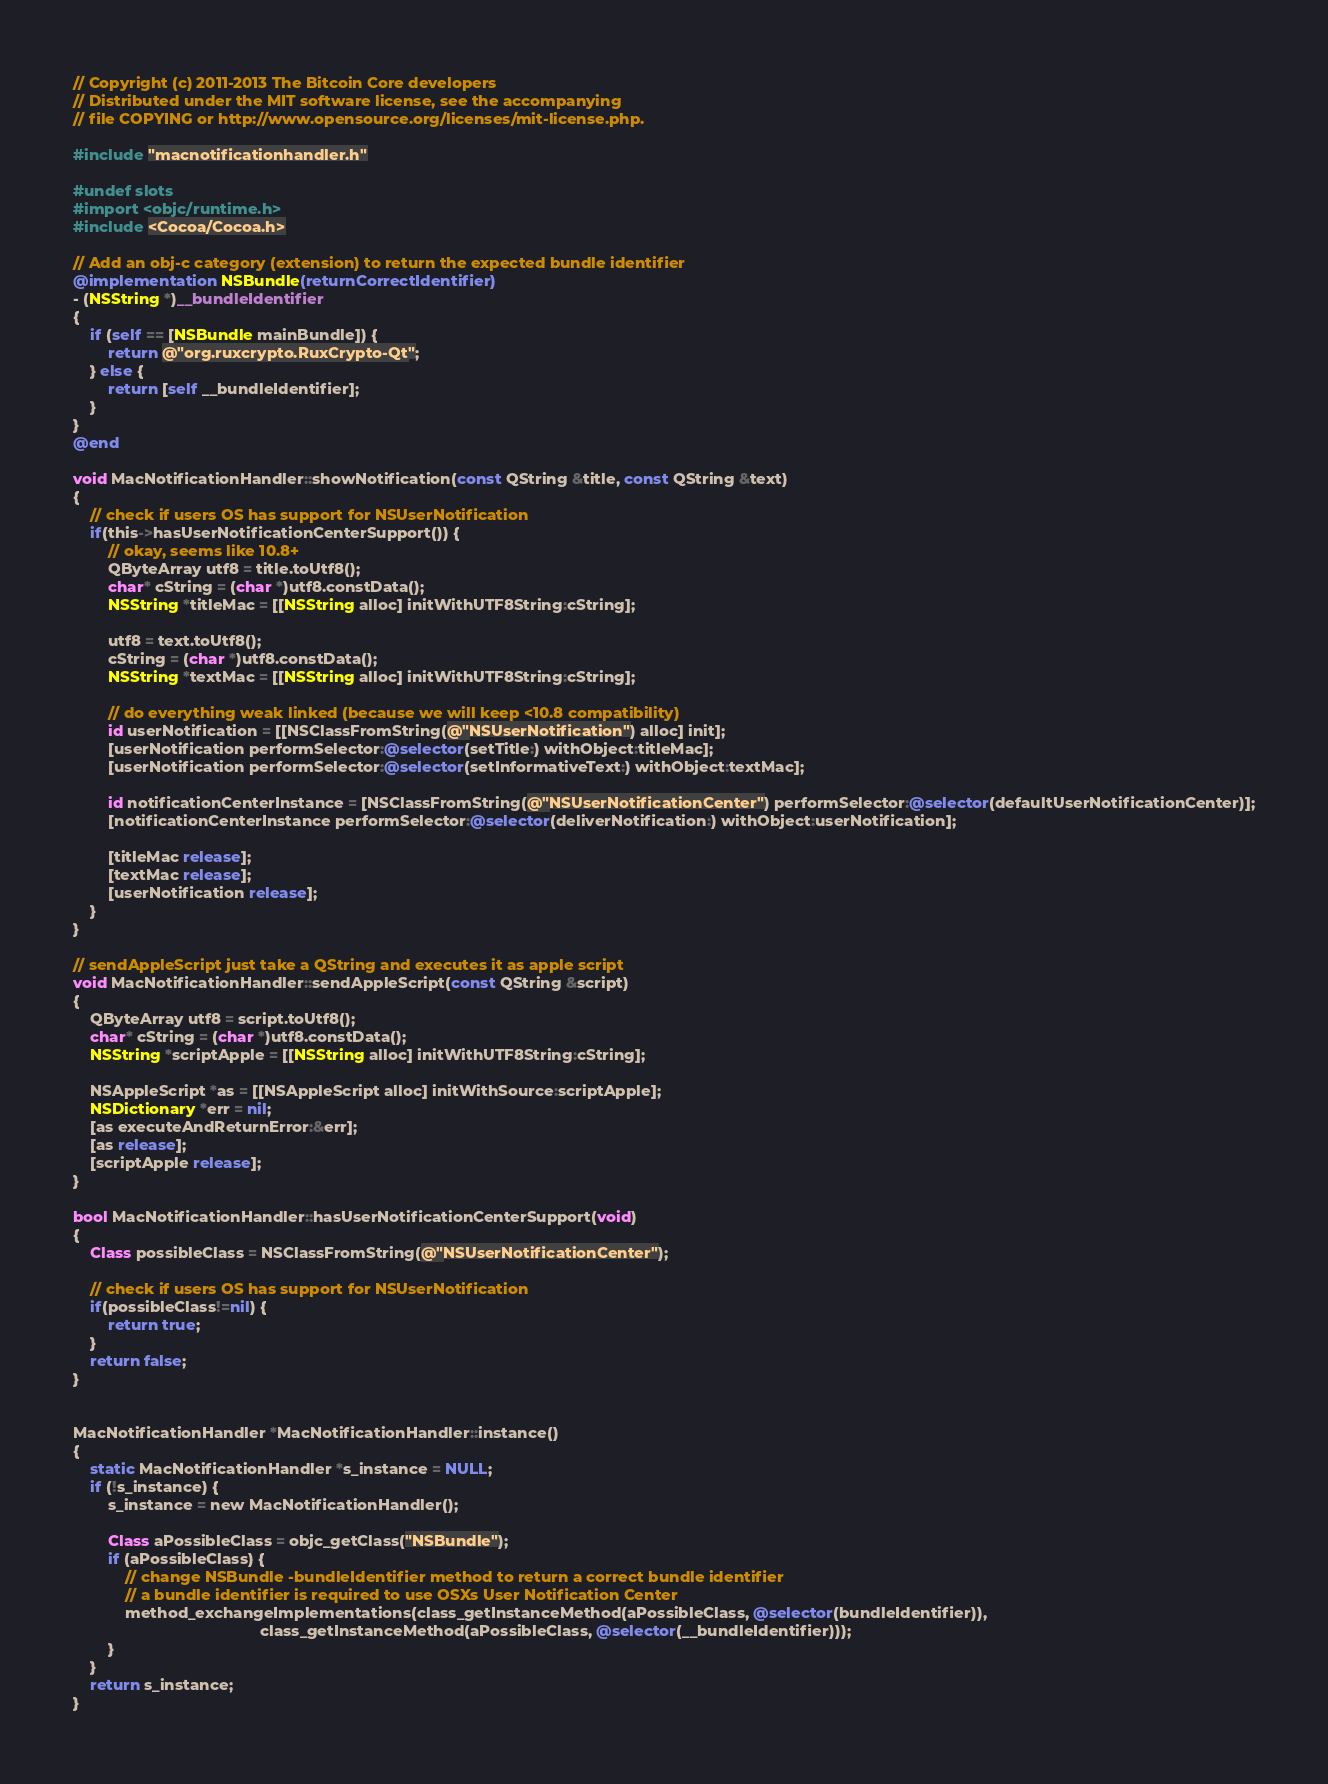<code> <loc_0><loc_0><loc_500><loc_500><_ObjectiveC_>// Copyright (c) 2011-2013 The Bitcoin Core developers
// Distributed under the MIT software license, see the accompanying
// file COPYING or http://www.opensource.org/licenses/mit-license.php.

#include "macnotificationhandler.h"

#undef slots
#import <objc/runtime.h>
#include <Cocoa/Cocoa.h>

// Add an obj-c category (extension) to return the expected bundle identifier
@implementation NSBundle(returnCorrectIdentifier)
- (NSString *)__bundleIdentifier
{
    if (self == [NSBundle mainBundle]) {
        return @"org.ruxcrypto.RuxCrypto-Qt";
    } else {
        return [self __bundleIdentifier];
    }
}
@end

void MacNotificationHandler::showNotification(const QString &title, const QString &text)
{
    // check if users OS has support for NSUserNotification
    if(this->hasUserNotificationCenterSupport()) {
        // okay, seems like 10.8+
        QByteArray utf8 = title.toUtf8();
        char* cString = (char *)utf8.constData();
        NSString *titleMac = [[NSString alloc] initWithUTF8String:cString];

        utf8 = text.toUtf8();
        cString = (char *)utf8.constData();
        NSString *textMac = [[NSString alloc] initWithUTF8String:cString];

        // do everything weak linked (because we will keep <10.8 compatibility)
        id userNotification = [[NSClassFromString(@"NSUserNotification") alloc] init];
        [userNotification performSelector:@selector(setTitle:) withObject:titleMac];
        [userNotification performSelector:@selector(setInformativeText:) withObject:textMac];

        id notificationCenterInstance = [NSClassFromString(@"NSUserNotificationCenter") performSelector:@selector(defaultUserNotificationCenter)];
        [notificationCenterInstance performSelector:@selector(deliverNotification:) withObject:userNotification];

        [titleMac release];
        [textMac release];
        [userNotification release];
    }
}

// sendAppleScript just take a QString and executes it as apple script
void MacNotificationHandler::sendAppleScript(const QString &script)
{
    QByteArray utf8 = script.toUtf8();
    char* cString = (char *)utf8.constData();
    NSString *scriptApple = [[NSString alloc] initWithUTF8String:cString];

    NSAppleScript *as = [[NSAppleScript alloc] initWithSource:scriptApple];
    NSDictionary *err = nil;
    [as executeAndReturnError:&err];
    [as release];
    [scriptApple release];
}

bool MacNotificationHandler::hasUserNotificationCenterSupport(void)
{
    Class possibleClass = NSClassFromString(@"NSUserNotificationCenter");

    // check if users OS has support for NSUserNotification
    if(possibleClass!=nil) {
        return true;
    }
    return false;
}


MacNotificationHandler *MacNotificationHandler::instance()
{
    static MacNotificationHandler *s_instance = NULL;
    if (!s_instance) {
        s_instance = new MacNotificationHandler();
        
        Class aPossibleClass = objc_getClass("NSBundle");
        if (aPossibleClass) {
            // change NSBundle -bundleIdentifier method to return a correct bundle identifier
            // a bundle identifier is required to use OSXs User Notification Center
            method_exchangeImplementations(class_getInstanceMethod(aPossibleClass, @selector(bundleIdentifier)),
                                           class_getInstanceMethod(aPossibleClass, @selector(__bundleIdentifier)));
        }
    }
    return s_instance;
}
</code> 